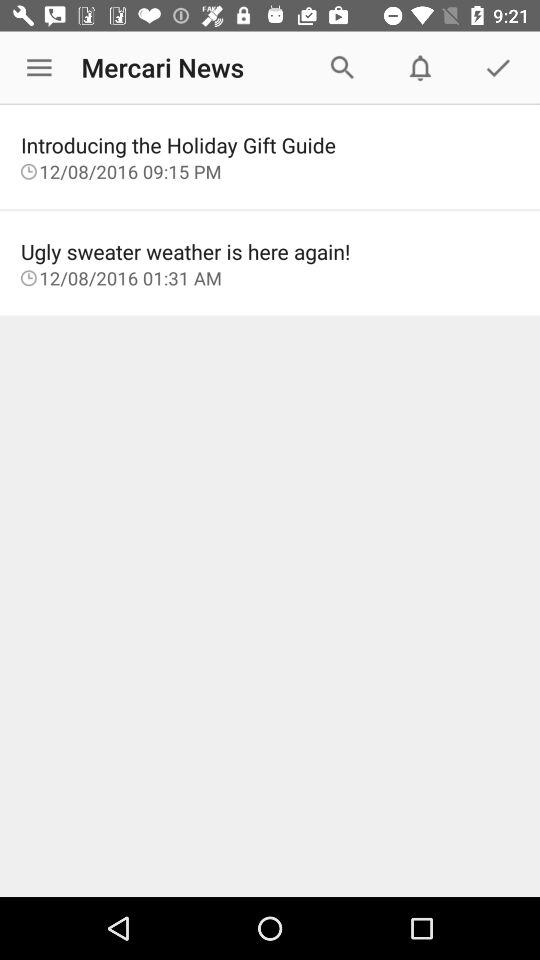What is the name of the application? The application name is "Mercari News". 